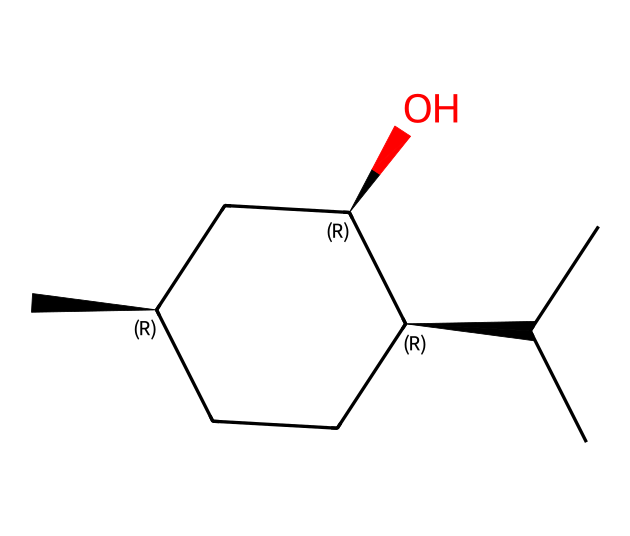What is the main functional group present in menthol? The SMILES representation includes an -OH group indicated by the "O" at the end, which signifies a hydroxyl group. This is characteristic of alcohols.
Answer: hydroxyl How many carbon atoms are present in menthol? By counting the "C" entries in the SMILES, there are 10 carbon atoms in the structure.
Answer: 10 How many stereocenters are present in menthol? The structure contains three chiral centers, as indicated by the "@" symbols in the SMILES, which mark the stereocenters.
Answer: 3 What type of chemical is menthol classified as? Menthol is a cyclic alcohol due to the presence of the hydroxyl group and a ring structure in its molecular makeup.
Answer: cyclic alcohol Does menthol contain any double bonds? There are no double bonds indicated in the SMILES representation, as the "C" atoms are all connected with single bonds.
Answer: no What is the total number of hydrogen atoms in menthol? Each carbon generally forms four bonds. Given that there are 10 carbons and accounting for the hydroxyl group, menthol has 20 hydrogen atoms as inferred from the structure.
Answer: 20 